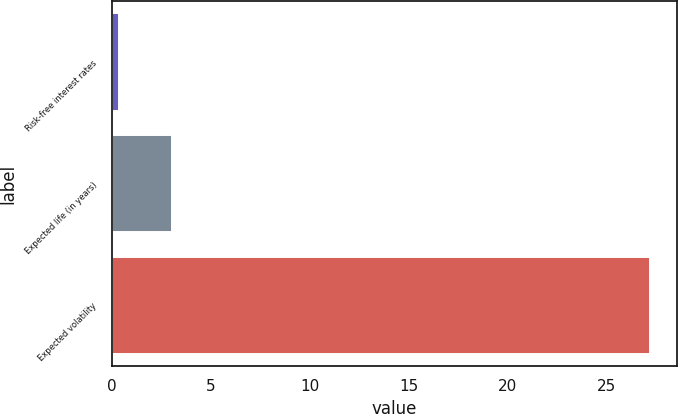Convert chart to OTSL. <chart><loc_0><loc_0><loc_500><loc_500><bar_chart><fcel>Risk-free interest rates<fcel>Expected life (in years)<fcel>Expected volatility<nl><fcel>0.34<fcel>3.03<fcel>27.2<nl></chart> 